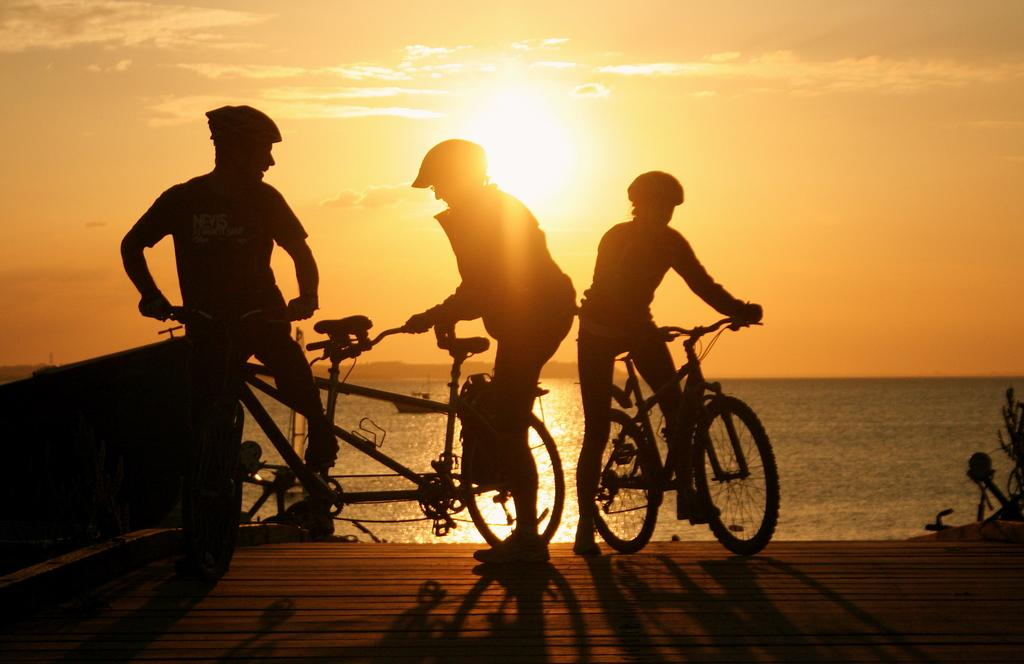How many people are in the image? There are three persons in the image. What are the persons wearing on their heads? The persons are wearing helmets. What are the persons holding in the image? The persons are holding bicycles. Where are the bicycles located? The bicycles are on a platform. What can be seen in the background of the image? Sky and water are visible in the background of the image. What type of wax is being used by the persons in the image? There is no wax present in the image; the persons are wearing helmets and holding bicycles. What religious beliefs are being practiced by the persons in the image? There is no indication of any religious beliefs being practiced in the image; the focus is on the persons and their bicycles. 